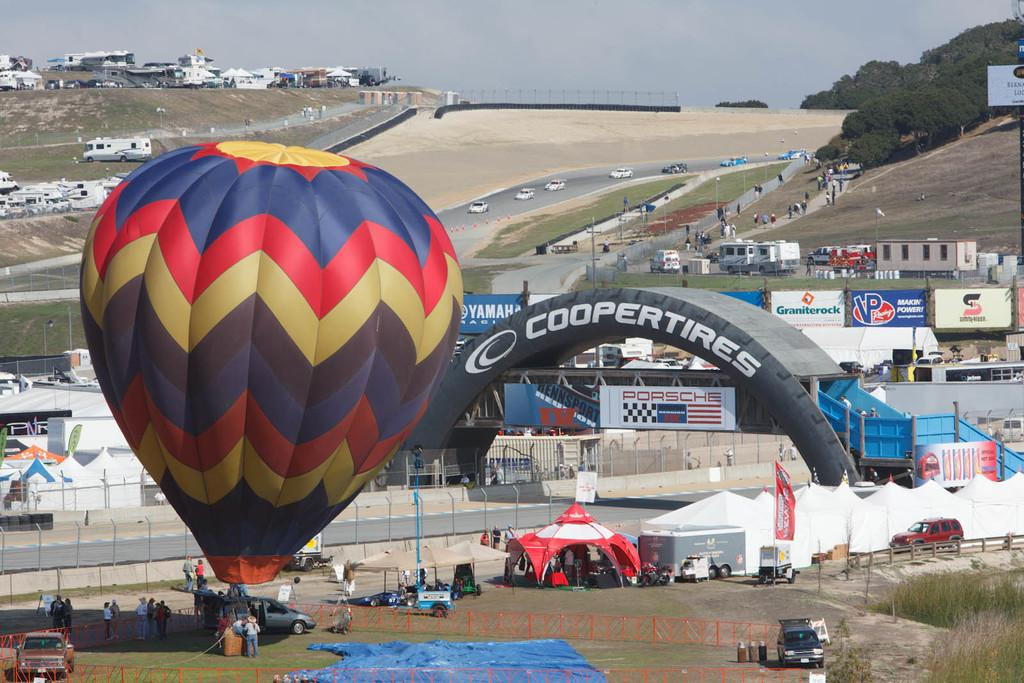<image>
Give a short and clear explanation of the subsequent image. A bridge over a race track is an advertisement for cooper tires. 